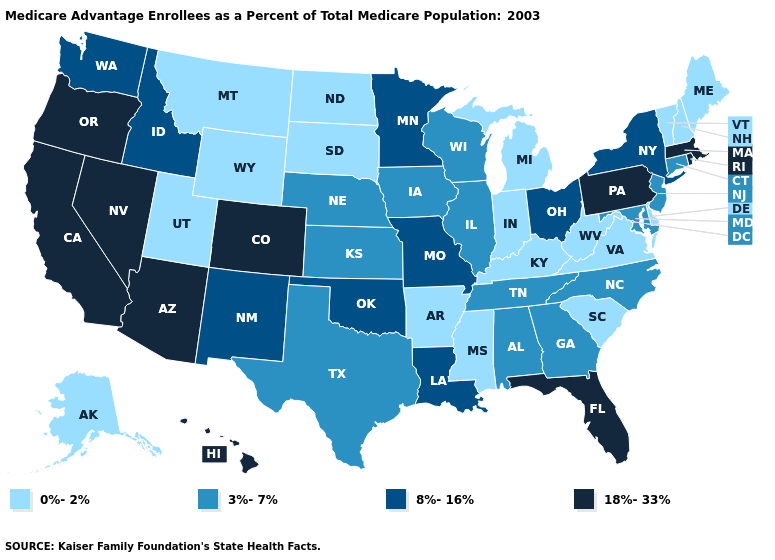Which states have the highest value in the USA?
Concise answer only. Arizona, California, Colorado, Florida, Hawaii, Massachusetts, Nevada, Oregon, Pennsylvania, Rhode Island. Name the states that have a value in the range 18%-33%?
Be succinct. Arizona, California, Colorado, Florida, Hawaii, Massachusetts, Nevada, Oregon, Pennsylvania, Rhode Island. What is the value of Massachusetts?
Concise answer only. 18%-33%. Does the first symbol in the legend represent the smallest category?
Keep it brief. Yes. What is the value of Nevada?
Keep it brief. 18%-33%. Name the states that have a value in the range 18%-33%?
Write a very short answer. Arizona, California, Colorado, Florida, Hawaii, Massachusetts, Nevada, Oregon, Pennsylvania, Rhode Island. What is the value of Connecticut?
Answer briefly. 3%-7%. What is the lowest value in the USA?
Short answer required. 0%-2%. Among the states that border Idaho , which have the highest value?
Concise answer only. Nevada, Oregon. What is the highest value in the South ?
Give a very brief answer. 18%-33%. Among the states that border Alabama , does Florida have the highest value?
Give a very brief answer. Yes. What is the highest value in the USA?
Answer briefly. 18%-33%. Name the states that have a value in the range 18%-33%?
Be succinct. Arizona, California, Colorado, Florida, Hawaii, Massachusetts, Nevada, Oregon, Pennsylvania, Rhode Island. What is the lowest value in states that border Illinois?
Write a very short answer. 0%-2%. What is the value of Arkansas?
Answer briefly. 0%-2%. 